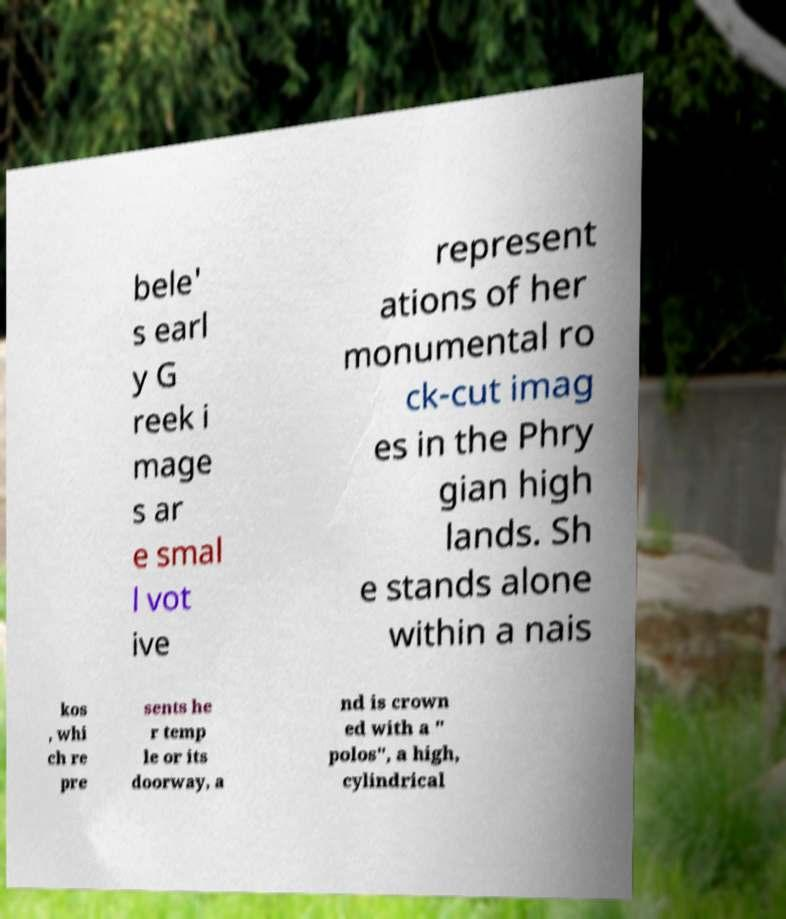Could you assist in decoding the text presented in this image and type it out clearly? bele' s earl y G reek i mage s ar e smal l vot ive represent ations of her monumental ro ck-cut imag es in the Phry gian high lands. Sh e stands alone within a nais kos , whi ch re pre sents he r temp le or its doorway, a nd is crown ed with a " polos", a high, cylindrical 